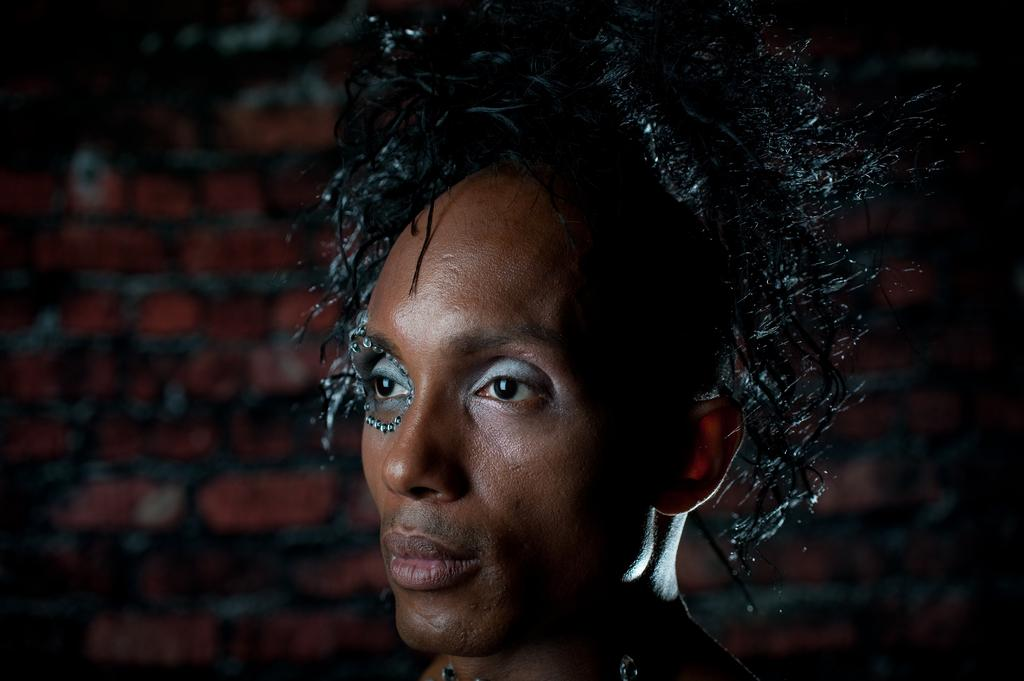What is the main subject of the image? The main subject of the image is a man's face. How is the man's face depicted in the image? The man's face is blurred in the background. What type of net can be seen in the image? There is no net present in the image; it only features a man's face. What is the man cooking in the image? There is no cooking activity depicted in the image, as it only shows a man's face. 